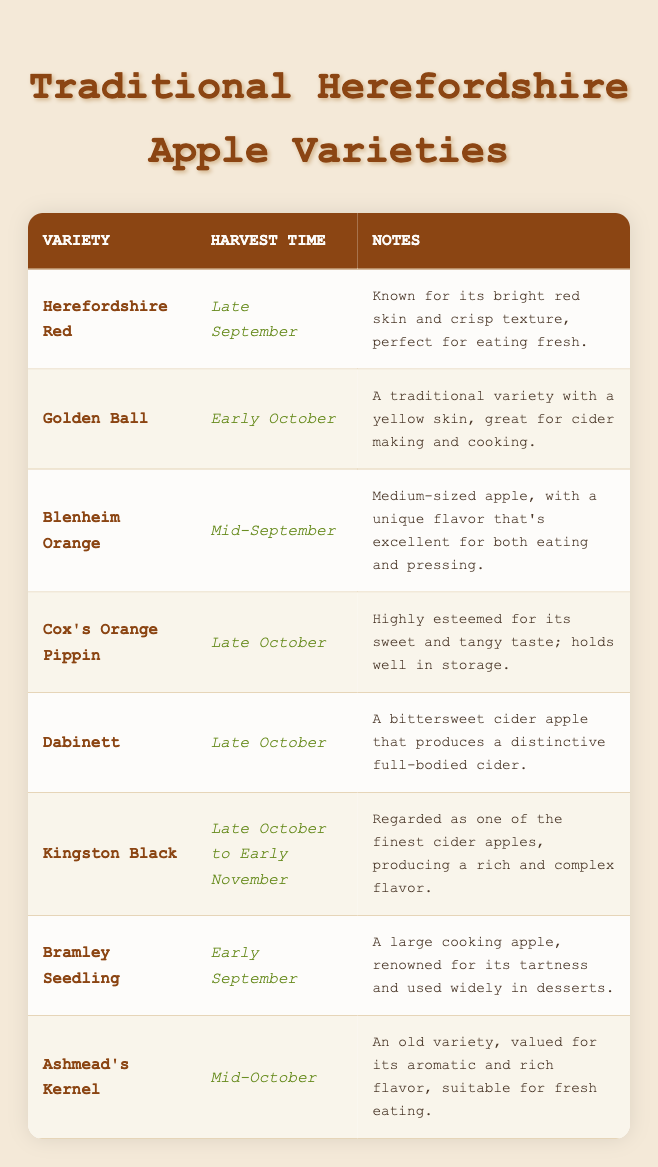What is the harvest time for Herefordshire Red apples? The harvest time for Herefordshire Red apples is listed directly in the table as "Late September."
Answer: Late September Which apple variety is known for being a large cooking apple? The variety known for being a large cooking apple is Bramley Seedling, as indicated in the notes in the table.
Answer: Bramley Seedling How many apple varieties have a harvest time in late October? There are three varieties with harvest times listed as late October: Cox's Orange Pippin, Dabinett, and Kingston Black.
Answer: 3 Is Ashmead's Kernel suitable for fresh eating? Yes, Ashmead's Kernel is noted in the table as having an aromatic and rich flavor, making it suitable for fresh eating.
Answer: Yes What is the difference in harvest times between Bramley Seedling and Golden Ball? Bramley Seedling is harvested in early September, while Golden Ball is harvested in early October. The difference between early September and early October is approximately one month.
Answer: 1 month Which apple variety is reputed for its use in cider making? The variety most noted for its use in cider making is Dabinett, as mentioned in the notes that specify it produces a distinctive full-bodied cider.
Answer: Dabinett What is the most common harvest time for the listed apple varieties? The harvest times in the table vary from early September to early November, but "Late October" is the most frequent, appearing three times (Cox's Orange Pippin, Dabinett, Kingston Black).
Answer: Late October Are there any varieties harvested before mid-September? Yes, both Bramley Seedling and Herefordshire Red are harvested before mid-September, with Bramley Seedling harvested in early September and Herefordshire Red in late September.
Answer: Yes Which apple variety has the longest harvest time range? Kingston Black has the longest harvest time range, spanning from late October to early November.
Answer: Kingston Black 